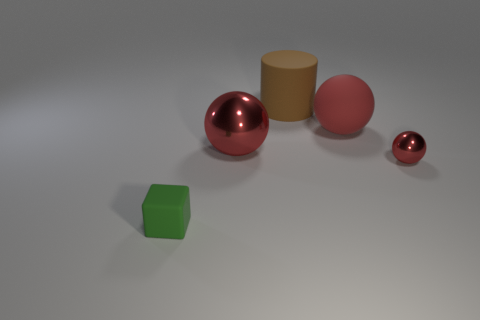Add 3 big red things. How many objects exist? 8 Subtract all spheres. How many objects are left? 2 Add 5 balls. How many balls exist? 8 Subtract 0 brown spheres. How many objects are left? 5 Subtract all big matte things. Subtract all tiny red metal objects. How many objects are left? 2 Add 2 small green matte things. How many small green matte things are left? 3 